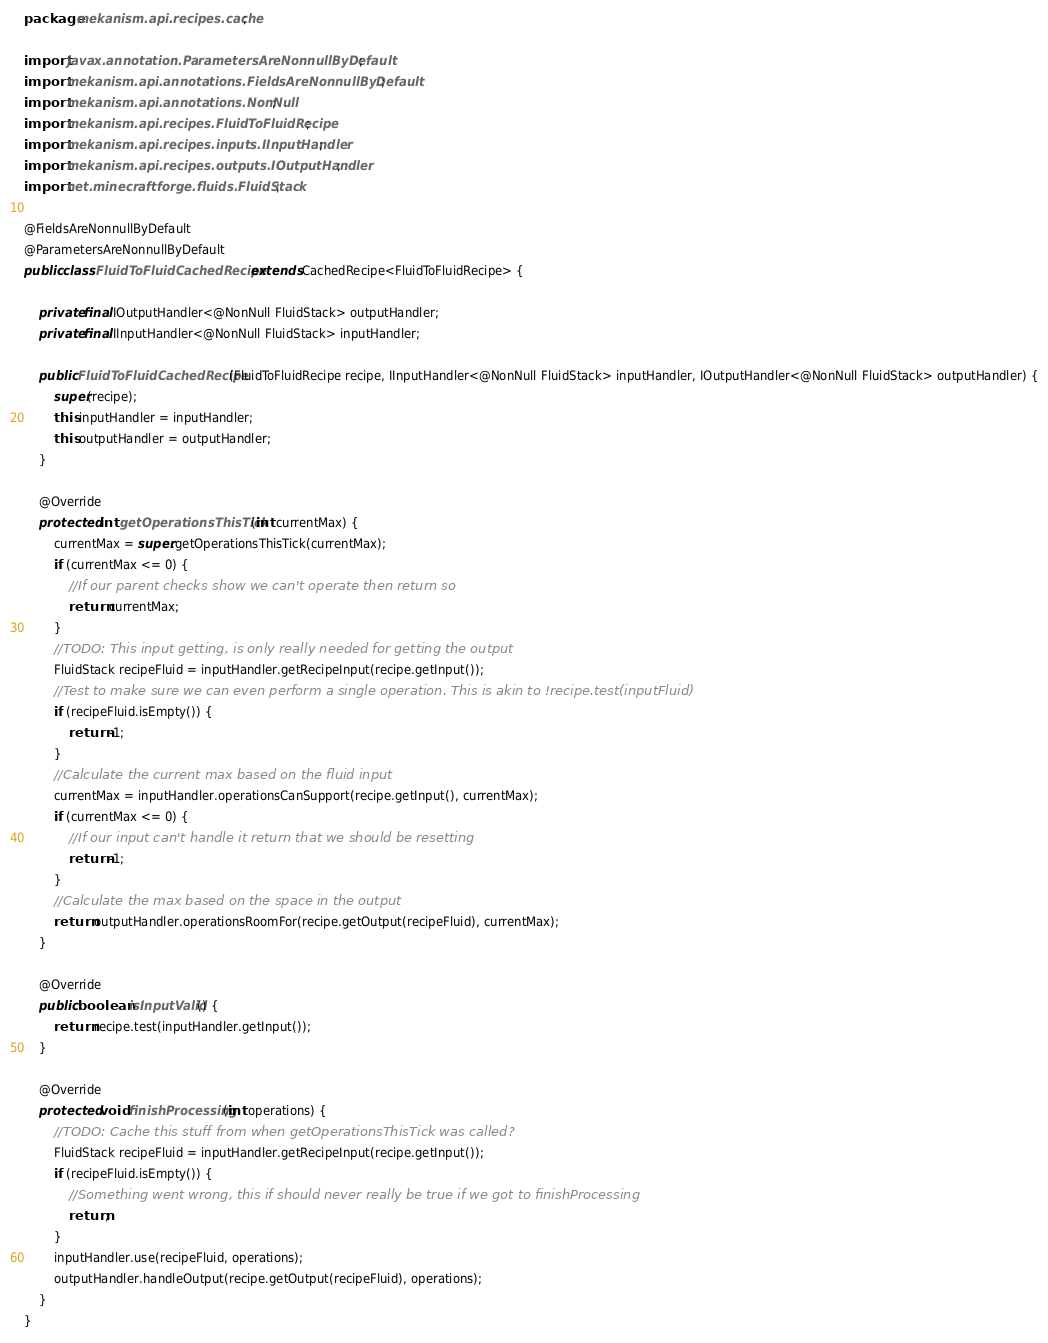<code> <loc_0><loc_0><loc_500><loc_500><_Java_>package mekanism.api.recipes.cache;

import javax.annotation.ParametersAreNonnullByDefault;
import mekanism.api.annotations.FieldsAreNonnullByDefault;
import mekanism.api.annotations.NonNull;
import mekanism.api.recipes.FluidToFluidRecipe;
import mekanism.api.recipes.inputs.IInputHandler;
import mekanism.api.recipes.outputs.IOutputHandler;
import net.minecraftforge.fluids.FluidStack;

@FieldsAreNonnullByDefault
@ParametersAreNonnullByDefault
public class FluidToFluidCachedRecipe extends CachedRecipe<FluidToFluidRecipe> {

    private final IOutputHandler<@NonNull FluidStack> outputHandler;
    private final IInputHandler<@NonNull FluidStack> inputHandler;

    public FluidToFluidCachedRecipe(FluidToFluidRecipe recipe, IInputHandler<@NonNull FluidStack> inputHandler, IOutputHandler<@NonNull FluidStack> outputHandler) {
        super(recipe);
        this.inputHandler = inputHandler;
        this.outputHandler = outputHandler;
    }

    @Override
    protected int getOperationsThisTick(int currentMax) {
        currentMax = super.getOperationsThisTick(currentMax);
        if (currentMax <= 0) {
            //If our parent checks show we can't operate then return so
            return currentMax;
        }
        //TODO: This input getting, is only really needed for getting the output
        FluidStack recipeFluid = inputHandler.getRecipeInput(recipe.getInput());
        //Test to make sure we can even perform a single operation. This is akin to !recipe.test(inputFluid)
        if (recipeFluid.isEmpty()) {
            return -1;
        }
        //Calculate the current max based on the fluid input
        currentMax = inputHandler.operationsCanSupport(recipe.getInput(), currentMax);
        if (currentMax <= 0) {
            //If our input can't handle it return that we should be resetting
            return -1;
        }
        //Calculate the max based on the space in the output
        return outputHandler.operationsRoomFor(recipe.getOutput(recipeFluid), currentMax);
    }

    @Override
    public boolean isInputValid() {
        return recipe.test(inputHandler.getInput());
    }

    @Override
    protected void finishProcessing(int operations) {
        //TODO: Cache this stuff from when getOperationsThisTick was called?
        FluidStack recipeFluid = inputHandler.getRecipeInput(recipe.getInput());
        if (recipeFluid.isEmpty()) {
            //Something went wrong, this if should never really be true if we got to finishProcessing
            return;
        }
        inputHandler.use(recipeFluid, operations);
        outputHandler.handleOutput(recipe.getOutput(recipeFluid), operations);
    }
}</code> 